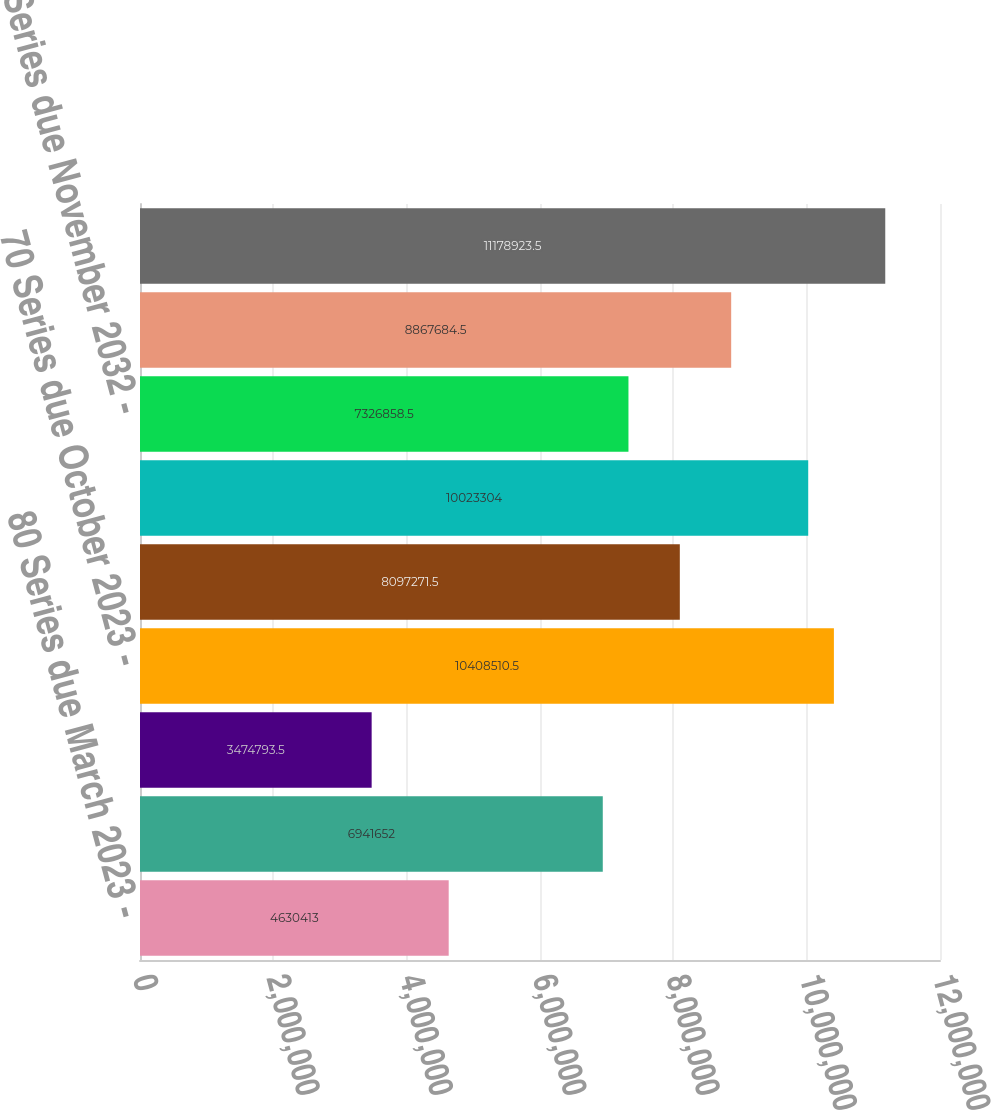Convert chart. <chart><loc_0><loc_0><loc_500><loc_500><bar_chart><fcel>80 Series due March 2023 -<fcel>77 Series due July 2023 -<fcel>755 Series due September 2023<fcel>70 Series due October 2023 -<fcel>67 Series due April 2032 -<fcel>76 Series due April 2032 -<fcel>60 Series due November 2032 -<fcel>725 Series due December 2032 -<fcel>Total mortgage bonds<nl><fcel>4.63041e+06<fcel>6.94165e+06<fcel>3.47479e+06<fcel>1.04085e+07<fcel>8.09727e+06<fcel>1.00233e+07<fcel>7.32686e+06<fcel>8.86768e+06<fcel>1.11789e+07<nl></chart> 